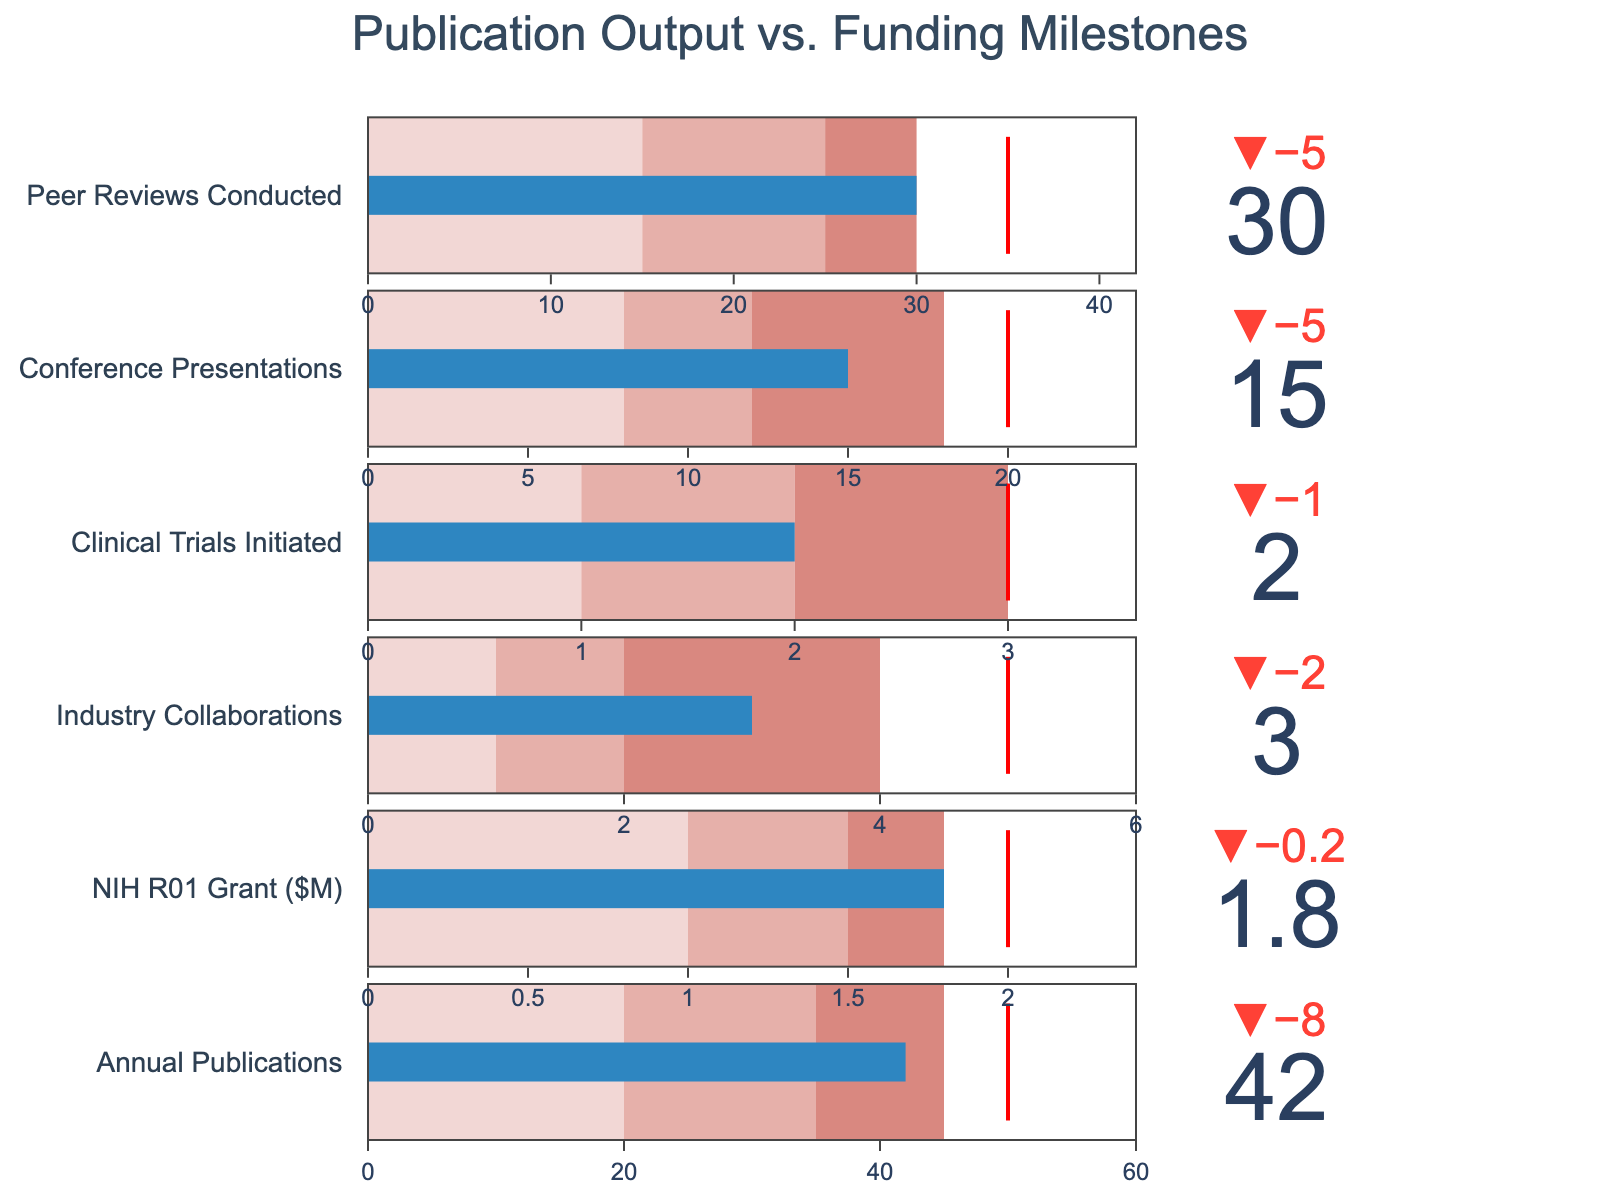How many elements are shown in the Bullet Chart? There are six rows, each representing a different metric; hence, the chart has six elements.
Answer: six What is the title of the chart? The title is at the top of the chart in a large font. It reads "Publication Output vs. Funding Milestones".
Answer: Publication Output vs. Funding Milestones Which metric has the highest target value? Looking at the target values listed on the chart, the "Annual Publications" metric has the highest target value of 50.
Answer: Annual Publications What is the difference between the actual values of "NIH R01 Grant ($M)" and "Industry Collaborations"? The actual value for "NIH R01 Grant ($M)" is 1.8, while for "Industry Collaborations", it is 3. Subtracting 1.8 from 3 gives the difference.
Answer: 1.2 What is the total of actual values for "Conference Presentations" and "Peer Reviews Conducted"? Summing the actual values of "Conference Presentations" (15) and "Peer Reviews Conducted" (30) results in a total.
Answer: 45 Which metric has the smallest actual value compared to its target value? By subtracting the target value from the actual value for each metric, "Clinical Trials Initiated" has the smallest result since 2 (actual) - 3 (target) = -1.
Answer: Clinical Trials Initiated Which metric achieved the highest percentage of its target value? Calculate the percentage of the target value achieved for each metric and compare them. "NIH R01 Grant ($M)" achieved 1.8/2.0 = 90%, which is the highest.
Answer: NIH R01 Grant ($M) In the "Annual Publications" metric, which color segment represents a range that includes the actual value? The actual value of 42 falls within the range represented by the third color segment (45) in the "Annual Publications" bullet chart.
Answer: third color segment What is the threshold line's color in each bullet chart? Each bullet chart has a red line indicating the target threshold.
Answer: red 